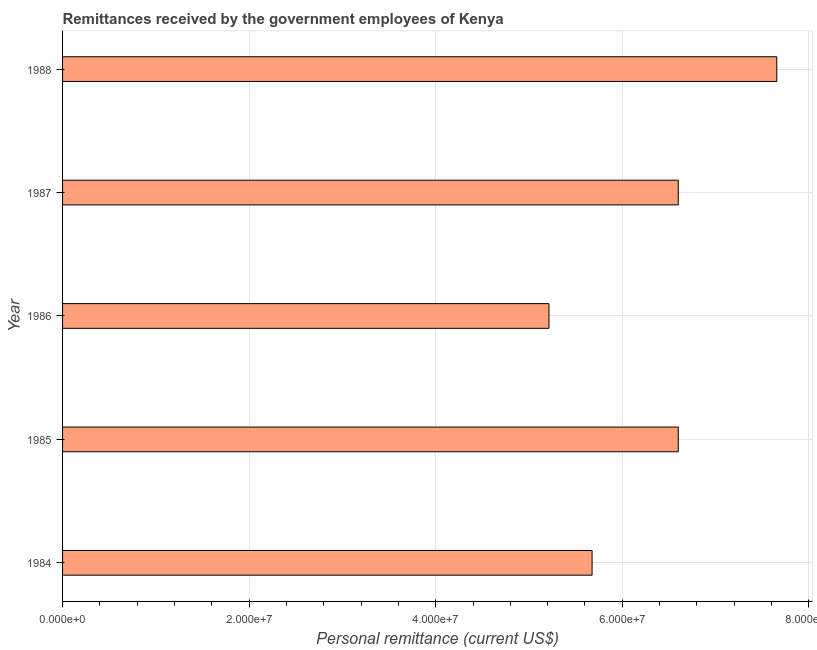Does the graph contain any zero values?
Keep it short and to the point. No. What is the title of the graph?
Provide a succinct answer. Remittances received by the government employees of Kenya. What is the label or title of the X-axis?
Your response must be concise. Personal remittance (current US$). What is the label or title of the Y-axis?
Offer a very short reply. Year. What is the personal remittances in 1988?
Make the answer very short. 7.66e+07. Across all years, what is the maximum personal remittances?
Your answer should be compact. 7.66e+07. Across all years, what is the minimum personal remittances?
Keep it short and to the point. 5.21e+07. In which year was the personal remittances maximum?
Ensure brevity in your answer.  1988. In which year was the personal remittances minimum?
Your response must be concise. 1986. What is the sum of the personal remittances?
Your response must be concise. 3.17e+08. What is the difference between the personal remittances in 1984 and 1988?
Keep it short and to the point. -1.98e+07. What is the average personal remittances per year?
Make the answer very short. 6.35e+07. What is the median personal remittances?
Give a very brief answer. 6.60e+07. In how many years, is the personal remittances greater than 60000000 US$?
Your response must be concise. 3. Do a majority of the years between 1986 and 1985 (inclusive) have personal remittances greater than 40000000 US$?
Make the answer very short. No. What is the ratio of the personal remittances in 1986 to that in 1988?
Provide a succinct answer. 0.68. Is the personal remittances in 1987 less than that in 1988?
Offer a very short reply. Yes. What is the difference between the highest and the second highest personal remittances?
Provide a short and direct response. 1.06e+07. What is the difference between the highest and the lowest personal remittances?
Your answer should be compact. 2.44e+07. In how many years, is the personal remittances greater than the average personal remittances taken over all years?
Give a very brief answer. 3. How many bars are there?
Give a very brief answer. 5. Are all the bars in the graph horizontal?
Keep it short and to the point. Yes. Are the values on the major ticks of X-axis written in scientific E-notation?
Provide a short and direct response. Yes. What is the Personal remittance (current US$) in 1984?
Keep it short and to the point. 5.68e+07. What is the Personal remittance (current US$) in 1985?
Keep it short and to the point. 6.60e+07. What is the Personal remittance (current US$) in 1986?
Make the answer very short. 5.21e+07. What is the Personal remittance (current US$) of 1987?
Provide a short and direct response. 6.60e+07. What is the Personal remittance (current US$) in 1988?
Offer a terse response. 7.66e+07. What is the difference between the Personal remittance (current US$) in 1984 and 1985?
Make the answer very short. -9.24e+06. What is the difference between the Personal remittance (current US$) in 1984 and 1986?
Your response must be concise. 4.62e+06. What is the difference between the Personal remittance (current US$) in 1984 and 1987?
Keep it short and to the point. -9.24e+06. What is the difference between the Personal remittance (current US$) in 1984 and 1988?
Provide a succinct answer. -1.98e+07. What is the difference between the Personal remittance (current US$) in 1985 and 1986?
Offer a terse response. 1.39e+07. What is the difference between the Personal remittance (current US$) in 1985 and 1987?
Provide a short and direct response. 0. What is the difference between the Personal remittance (current US$) in 1985 and 1988?
Keep it short and to the point. -1.06e+07. What is the difference between the Personal remittance (current US$) in 1986 and 1987?
Your answer should be very brief. -1.39e+07. What is the difference between the Personal remittance (current US$) in 1986 and 1988?
Provide a short and direct response. -2.44e+07. What is the difference between the Personal remittance (current US$) in 1987 and 1988?
Your answer should be very brief. -1.06e+07. What is the ratio of the Personal remittance (current US$) in 1984 to that in 1985?
Give a very brief answer. 0.86. What is the ratio of the Personal remittance (current US$) in 1984 to that in 1986?
Offer a terse response. 1.09. What is the ratio of the Personal remittance (current US$) in 1984 to that in 1987?
Offer a terse response. 0.86. What is the ratio of the Personal remittance (current US$) in 1984 to that in 1988?
Keep it short and to the point. 0.74. What is the ratio of the Personal remittance (current US$) in 1985 to that in 1986?
Give a very brief answer. 1.27. What is the ratio of the Personal remittance (current US$) in 1985 to that in 1988?
Provide a succinct answer. 0.86. What is the ratio of the Personal remittance (current US$) in 1986 to that in 1987?
Offer a terse response. 0.79. What is the ratio of the Personal remittance (current US$) in 1986 to that in 1988?
Offer a very short reply. 0.68. What is the ratio of the Personal remittance (current US$) in 1987 to that in 1988?
Ensure brevity in your answer.  0.86. 